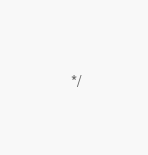Convert code to text. <code><loc_0><loc_0><loc_500><loc_500><_CSS_> */</code> 